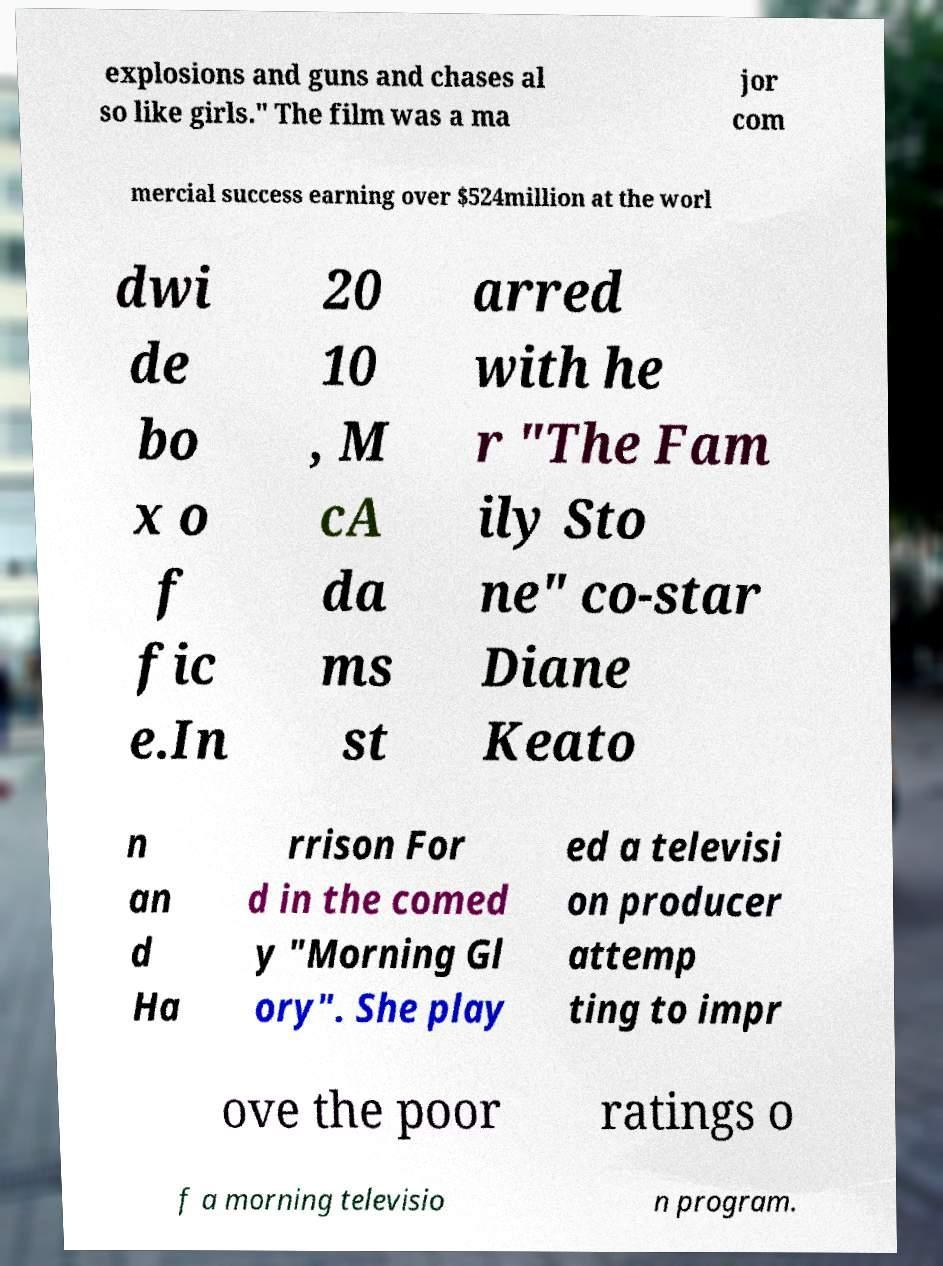Could you assist in decoding the text presented in this image and type it out clearly? explosions and guns and chases al so like girls." The film was a ma jor com mercial success earning over $524million at the worl dwi de bo x o f fic e.In 20 10 , M cA da ms st arred with he r "The Fam ily Sto ne" co-star Diane Keato n an d Ha rrison For d in the comed y "Morning Gl ory". She play ed a televisi on producer attemp ting to impr ove the poor ratings o f a morning televisio n program. 